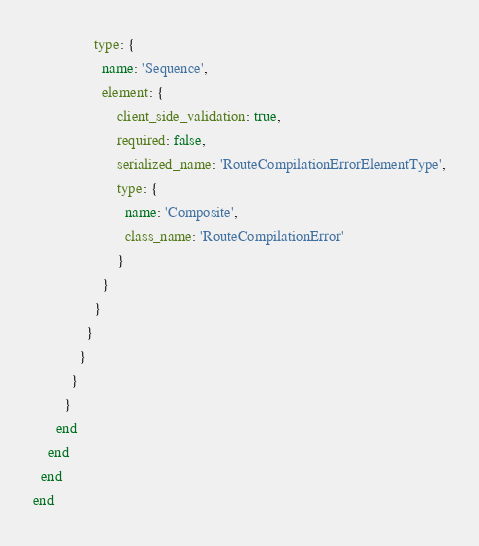Convert code to text. <code><loc_0><loc_0><loc_500><loc_500><_Ruby_>                type: {
                  name: 'Sequence',
                  element: {
                      client_side_validation: true,
                      required: false,
                      serialized_name: 'RouteCompilationErrorElementType',
                      type: {
                        name: 'Composite',
                        class_name: 'RouteCompilationError'
                      }
                  }
                }
              }
            }
          }
        }
      end
    end
  end
end
</code> 